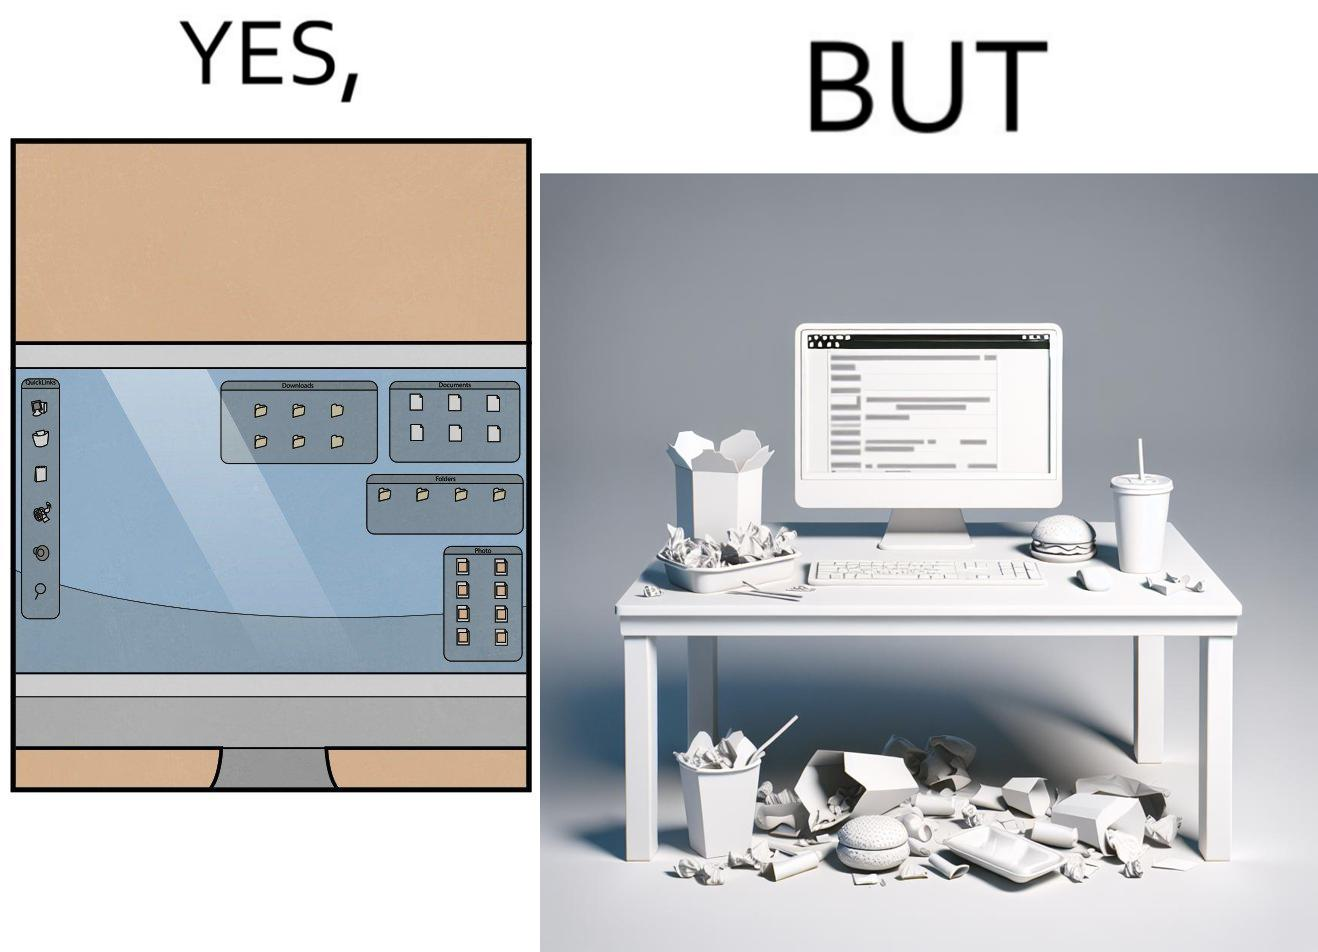Is this a satirical image? Yes, this image is satirical. 